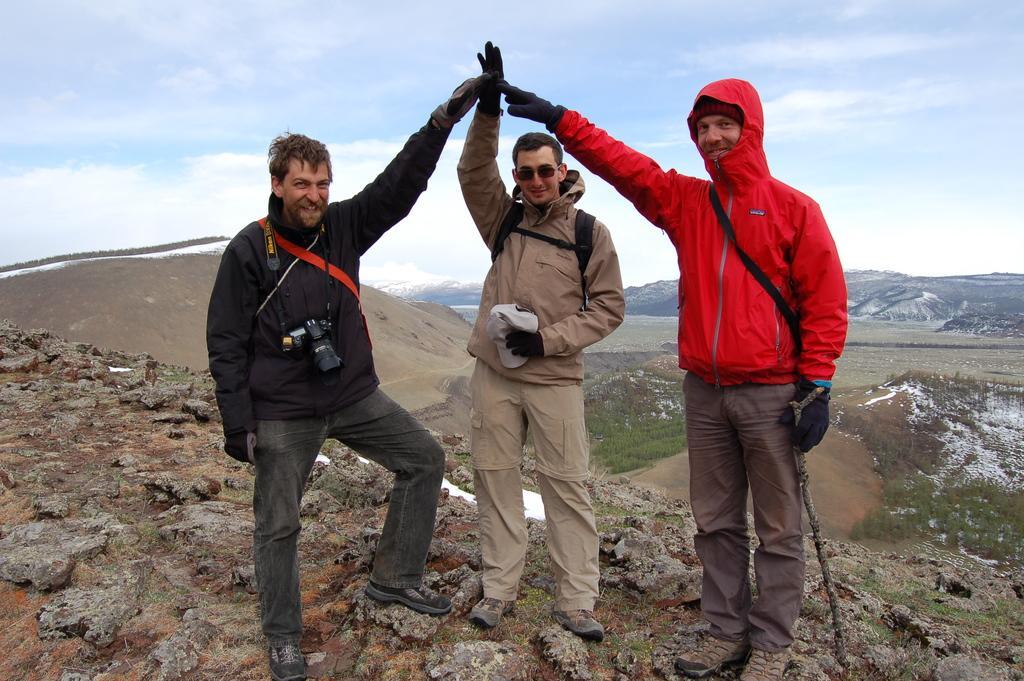Describe this image in one or two sentences. This picture is clicked outside the city. On the right there is a person wearing red color jacket, sling bag, smiling holding a stick and standing on the ground. In the center there is another person smiling, holding a cap and standing on the ground. On the left there is a man wearing black color jacket, camera, smiling and standing on the ground. In the background we can see the hills, green grass and the sky. 